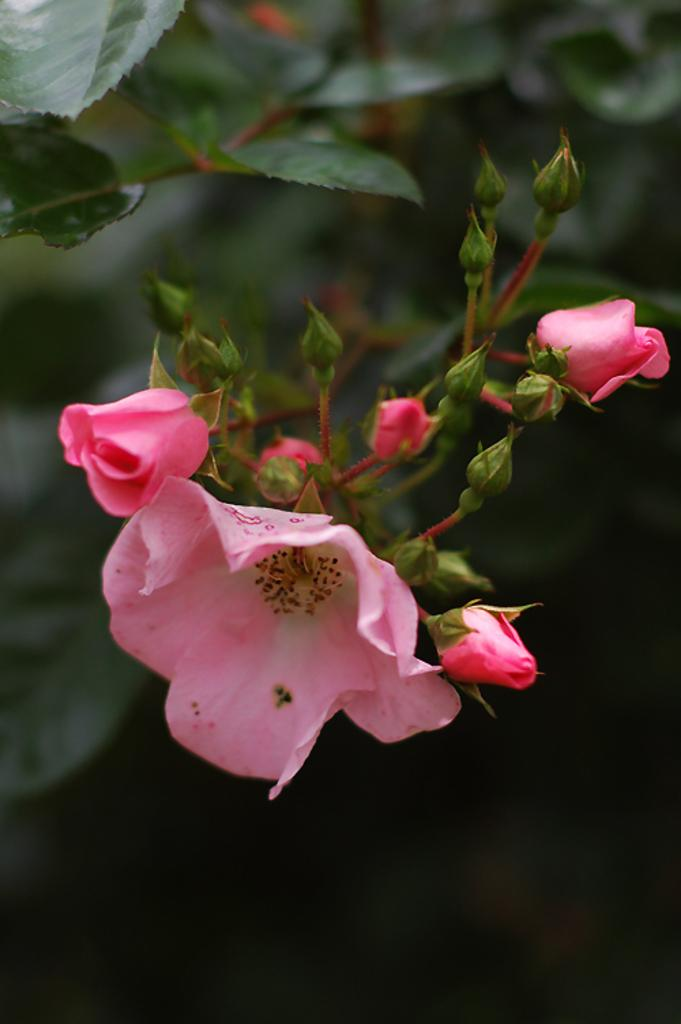What type of living organisms can be seen in the image? There are flowers in the image. What do the flowers belong to? The flowers belong to a plant. What type of company is responsible for the sorting of the scissors in the image? There are no scissors or any reference to a company in the image, so this question cannot be answered. 